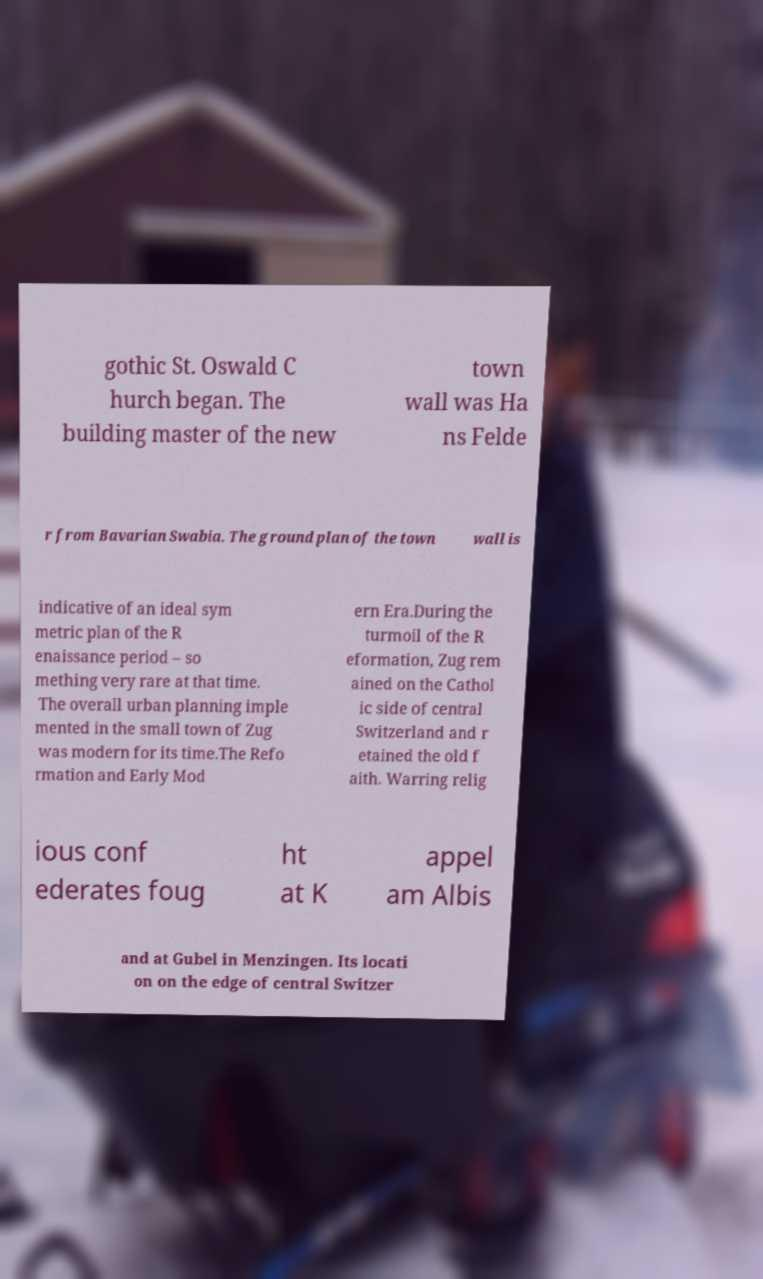I need the written content from this picture converted into text. Can you do that? gothic St. Oswald C hurch began. The building master of the new town wall was Ha ns Felde r from Bavarian Swabia. The ground plan of the town wall is indicative of an ideal sym metric plan of the R enaissance period – so mething very rare at that time. The overall urban planning imple mented in the small town of Zug was modern for its time.The Refo rmation and Early Mod ern Era.During the turmoil of the R eformation, Zug rem ained on the Cathol ic side of central Switzerland and r etained the old f aith. Warring relig ious conf ederates foug ht at K appel am Albis and at Gubel in Menzingen. Its locati on on the edge of central Switzer 